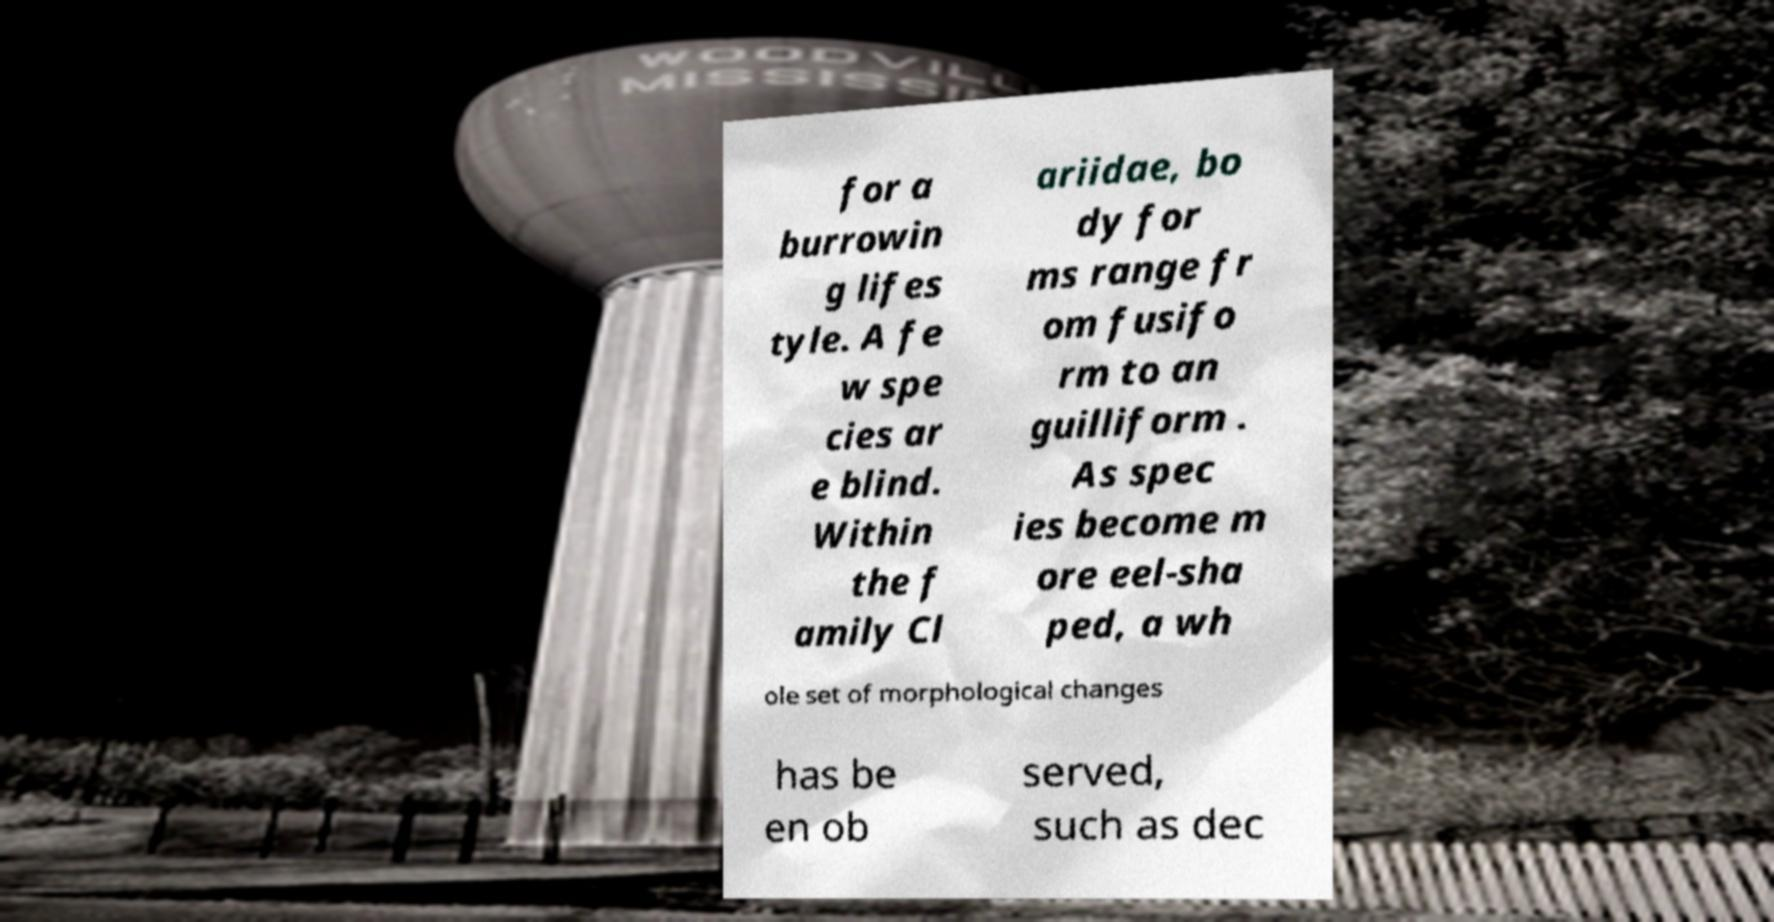Could you extract and type out the text from this image? for a burrowin g lifes tyle. A fe w spe cies ar e blind. Within the f amily Cl ariidae, bo dy for ms range fr om fusifo rm to an guilliform . As spec ies become m ore eel-sha ped, a wh ole set of morphological changes has be en ob served, such as dec 